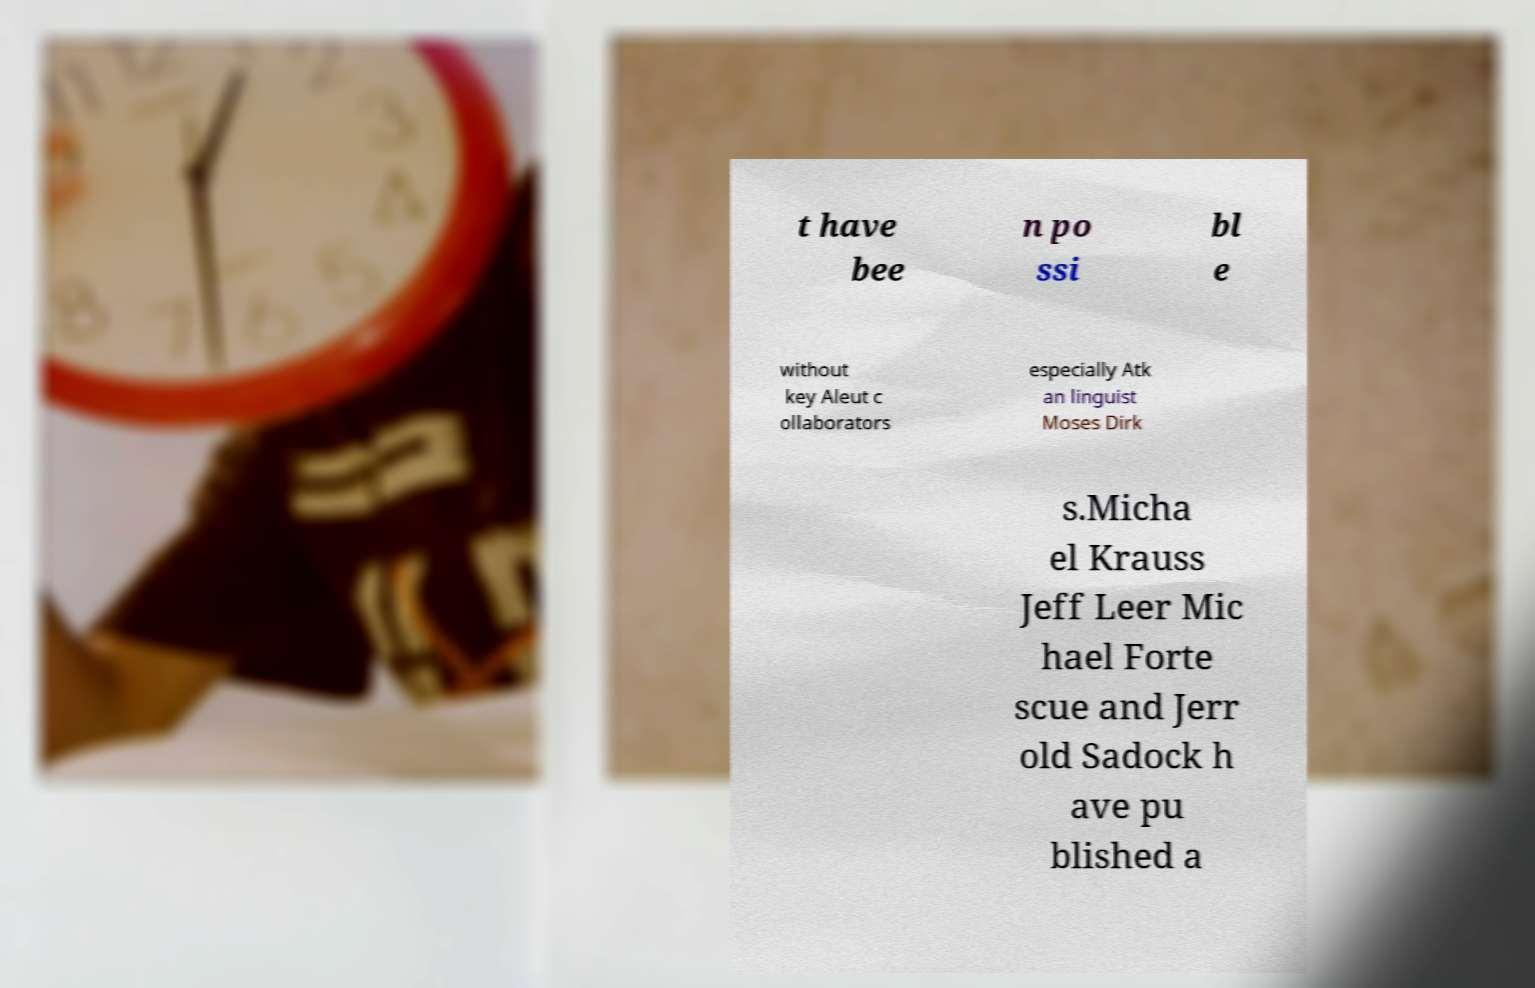I need the written content from this picture converted into text. Can you do that? t have bee n po ssi bl e without key Aleut c ollaborators especially Atk an linguist Moses Dirk s.Micha el Krauss Jeff Leer Mic hael Forte scue and Jerr old Sadock h ave pu blished a 